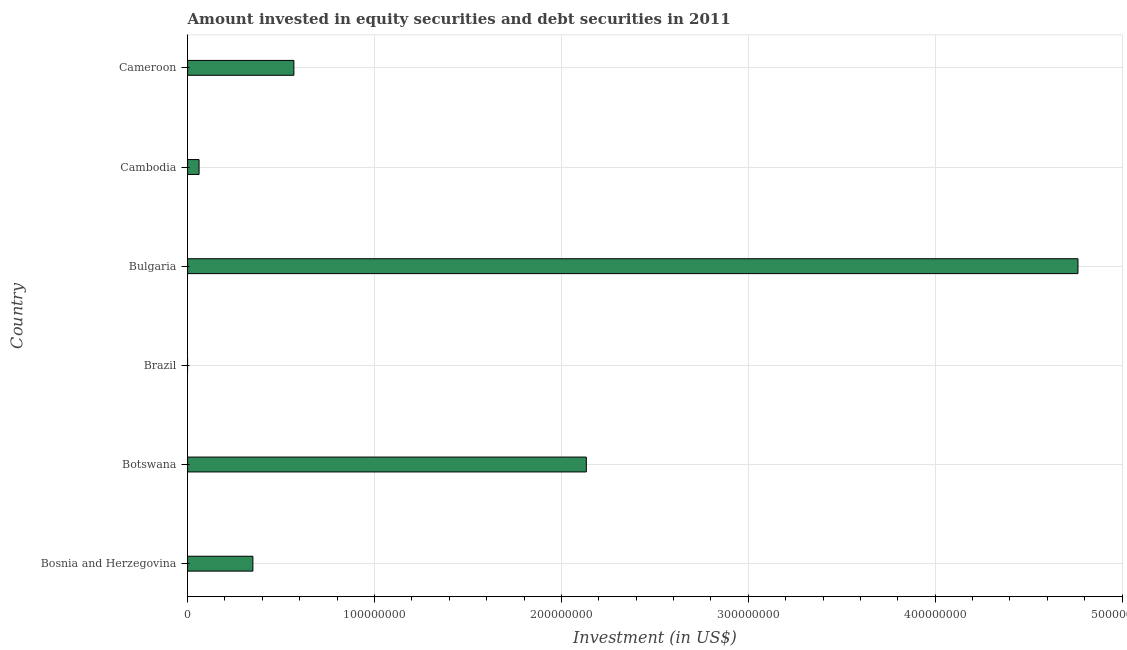Does the graph contain any zero values?
Provide a short and direct response. Yes. What is the title of the graph?
Offer a terse response. Amount invested in equity securities and debt securities in 2011. What is the label or title of the X-axis?
Provide a succinct answer. Investment (in US$). What is the portfolio investment in Bulgaria?
Provide a succinct answer. 4.76e+08. Across all countries, what is the maximum portfolio investment?
Make the answer very short. 4.76e+08. In which country was the portfolio investment maximum?
Give a very brief answer. Bulgaria. What is the sum of the portfolio investment?
Provide a succinct answer. 7.88e+08. What is the difference between the portfolio investment in Botswana and Cambodia?
Provide a succinct answer. 2.07e+08. What is the average portfolio investment per country?
Ensure brevity in your answer.  1.31e+08. What is the median portfolio investment?
Your answer should be very brief. 4.59e+07. What is the ratio of the portfolio investment in Bosnia and Herzegovina to that in Bulgaria?
Your response must be concise. 0.07. Is the portfolio investment in Botswana less than that in Bulgaria?
Keep it short and to the point. Yes. Is the difference between the portfolio investment in Bosnia and Herzegovina and Cameroon greater than the difference between any two countries?
Offer a very short reply. No. What is the difference between the highest and the second highest portfolio investment?
Your response must be concise. 2.63e+08. Is the sum of the portfolio investment in Bulgaria and Cameroon greater than the maximum portfolio investment across all countries?
Provide a succinct answer. Yes. What is the difference between the highest and the lowest portfolio investment?
Keep it short and to the point. 4.76e+08. In how many countries, is the portfolio investment greater than the average portfolio investment taken over all countries?
Provide a succinct answer. 2. Are all the bars in the graph horizontal?
Your response must be concise. Yes. Are the values on the major ticks of X-axis written in scientific E-notation?
Provide a succinct answer. No. What is the Investment (in US$) in Bosnia and Herzegovina?
Offer a very short reply. 3.49e+07. What is the Investment (in US$) in Botswana?
Ensure brevity in your answer.  2.13e+08. What is the Investment (in US$) of Brazil?
Ensure brevity in your answer.  0. What is the Investment (in US$) in Bulgaria?
Provide a short and direct response. 4.76e+08. What is the Investment (in US$) of Cambodia?
Provide a succinct answer. 6.14e+06. What is the Investment (in US$) of Cameroon?
Ensure brevity in your answer.  5.69e+07. What is the difference between the Investment (in US$) in Bosnia and Herzegovina and Botswana?
Give a very brief answer. -1.78e+08. What is the difference between the Investment (in US$) in Bosnia and Herzegovina and Bulgaria?
Give a very brief answer. -4.41e+08. What is the difference between the Investment (in US$) in Bosnia and Herzegovina and Cambodia?
Offer a terse response. 2.88e+07. What is the difference between the Investment (in US$) in Bosnia and Herzegovina and Cameroon?
Give a very brief answer. -2.19e+07. What is the difference between the Investment (in US$) in Botswana and Bulgaria?
Keep it short and to the point. -2.63e+08. What is the difference between the Investment (in US$) in Botswana and Cambodia?
Your answer should be very brief. 2.07e+08. What is the difference between the Investment (in US$) in Botswana and Cameroon?
Ensure brevity in your answer.  1.56e+08. What is the difference between the Investment (in US$) in Bulgaria and Cambodia?
Your answer should be very brief. 4.70e+08. What is the difference between the Investment (in US$) in Bulgaria and Cameroon?
Provide a short and direct response. 4.20e+08. What is the difference between the Investment (in US$) in Cambodia and Cameroon?
Provide a short and direct response. -5.07e+07. What is the ratio of the Investment (in US$) in Bosnia and Herzegovina to that in Botswana?
Ensure brevity in your answer.  0.16. What is the ratio of the Investment (in US$) in Bosnia and Herzegovina to that in Bulgaria?
Offer a terse response. 0.07. What is the ratio of the Investment (in US$) in Bosnia and Herzegovina to that in Cambodia?
Offer a terse response. 5.69. What is the ratio of the Investment (in US$) in Bosnia and Herzegovina to that in Cameroon?
Your answer should be very brief. 0.61. What is the ratio of the Investment (in US$) in Botswana to that in Bulgaria?
Ensure brevity in your answer.  0.45. What is the ratio of the Investment (in US$) in Botswana to that in Cambodia?
Ensure brevity in your answer.  34.76. What is the ratio of the Investment (in US$) in Botswana to that in Cameroon?
Your answer should be very brief. 3.75. What is the ratio of the Investment (in US$) in Bulgaria to that in Cambodia?
Keep it short and to the point. 77.62. What is the ratio of the Investment (in US$) in Bulgaria to that in Cameroon?
Give a very brief answer. 8.38. What is the ratio of the Investment (in US$) in Cambodia to that in Cameroon?
Provide a short and direct response. 0.11. 